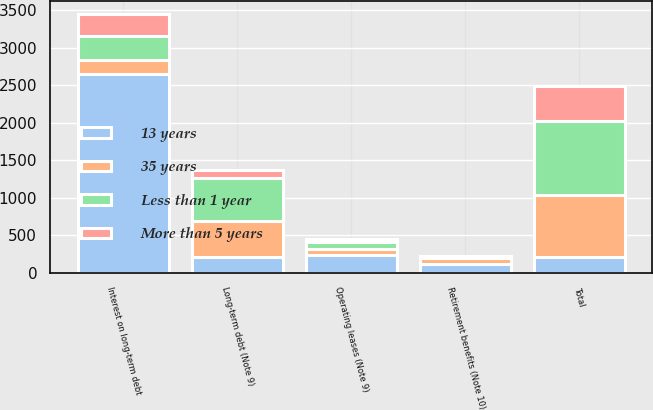<chart> <loc_0><loc_0><loc_500><loc_500><stacked_bar_chart><ecel><fcel>Long-term debt (Note 9)<fcel>Interest on long-term debt<fcel>Operating leases (Note 9)<fcel>Retirement benefits (Note 10)<fcel>Total<nl><fcel>13 years<fcel>214.5<fcel>2649<fcel>239<fcel>123<fcel>214.5<nl><fcel>35 years<fcel>475<fcel>190<fcel>81<fcel>75<fcel>821<nl><fcel>Less than 1 year<fcel>569<fcel>318<fcel>92<fcel>12<fcel>991<nl><fcel>More than 5 years<fcel>114<fcel>299<fcel>34<fcel>11<fcel>458<nl></chart> 